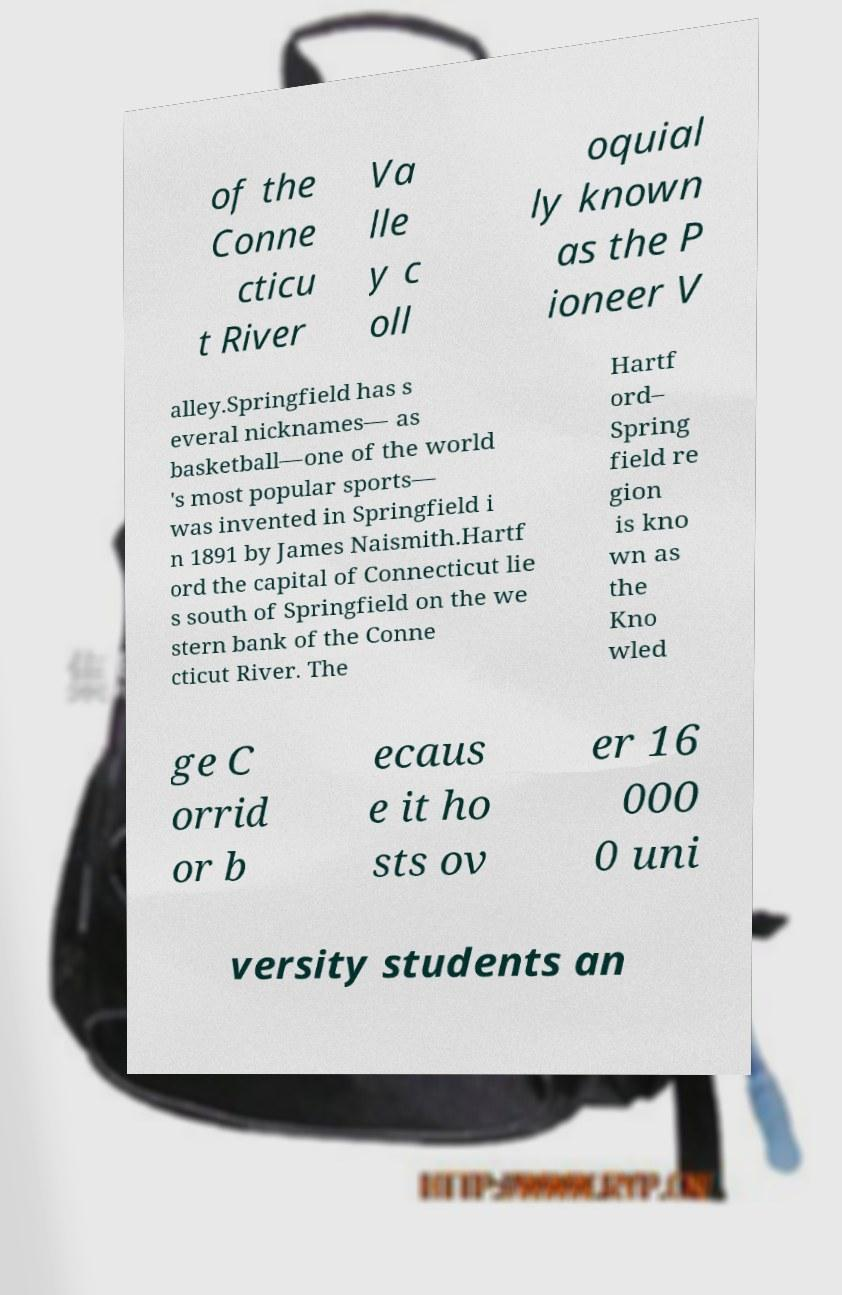Please read and relay the text visible in this image. What does it say? of the Conne cticu t River Va lle y c oll oquial ly known as the P ioneer V alley.Springfield has s everal nicknames— as basketball—one of the world 's most popular sports— was invented in Springfield i n 1891 by James Naismith.Hartf ord the capital of Connecticut lie s south of Springfield on the we stern bank of the Conne cticut River. The Hartf ord– Spring field re gion is kno wn as the Kno wled ge C orrid or b ecaus e it ho sts ov er 16 000 0 uni versity students an 